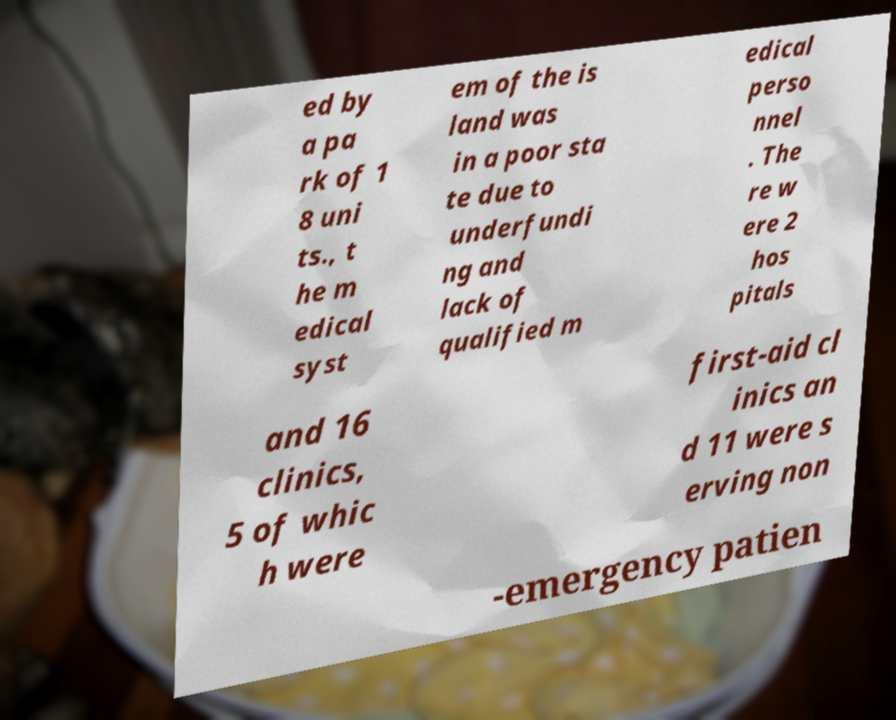Please identify and transcribe the text found in this image. ed by a pa rk of 1 8 uni ts., t he m edical syst em of the is land was in a poor sta te due to underfundi ng and lack of qualified m edical perso nnel . The re w ere 2 hos pitals and 16 clinics, 5 of whic h were first-aid cl inics an d 11 were s erving non -emergency patien 